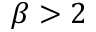<formula> <loc_0><loc_0><loc_500><loc_500>\beta > 2</formula> 